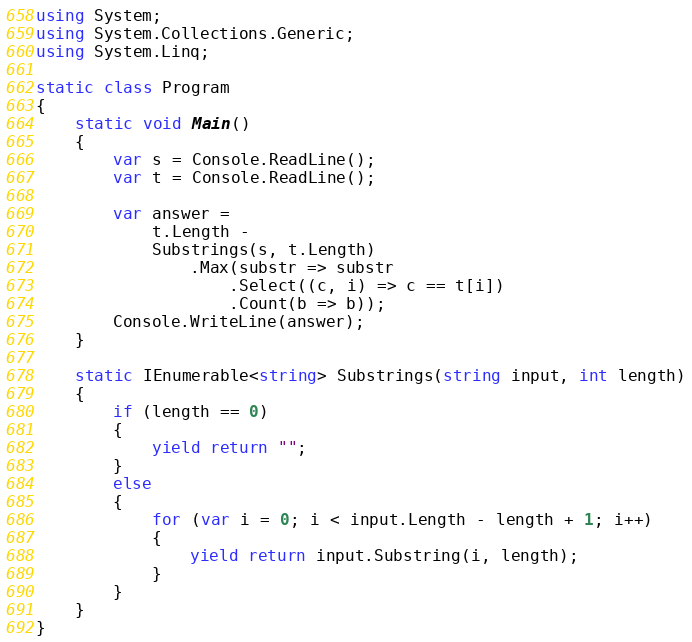Convert code to text. <code><loc_0><loc_0><loc_500><loc_500><_C#_>using System;
using System.Collections.Generic;
using System.Linq;

static class Program
{
    static void Main()
    {
        var s = Console.ReadLine();
        var t = Console.ReadLine();

        var answer =
            t.Length -
            Substrings(s, t.Length)
                .Max(substr => substr
                    .Select((c, i) => c == t[i])
                    .Count(b => b));
        Console.WriteLine(answer);
    }

    static IEnumerable<string> Substrings(string input, int length)
    {
        if (length == 0)
        {
            yield return "";
        }
        else
        {
            for (var i = 0; i < input.Length - length + 1; i++)
            {
                yield return input.Substring(i, length);
            }
        }
    }
}</code> 